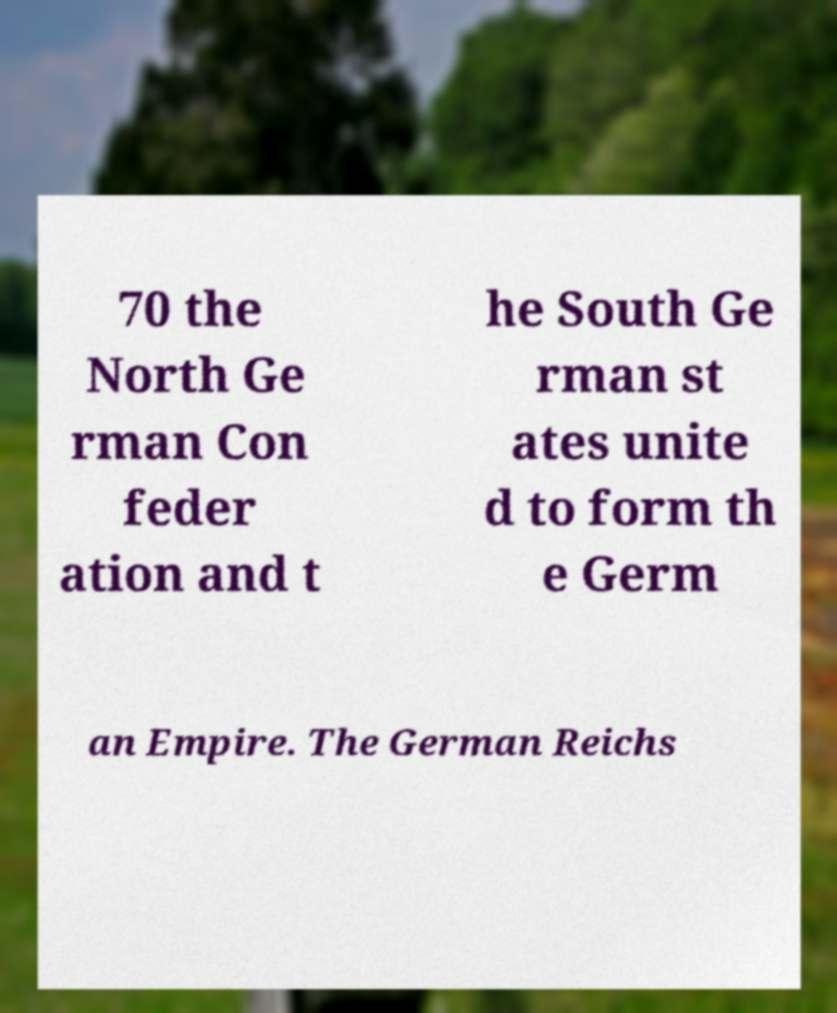For documentation purposes, I need the text within this image transcribed. Could you provide that? 70 the North Ge rman Con feder ation and t he South Ge rman st ates unite d to form th e Germ an Empire. The German Reichs 